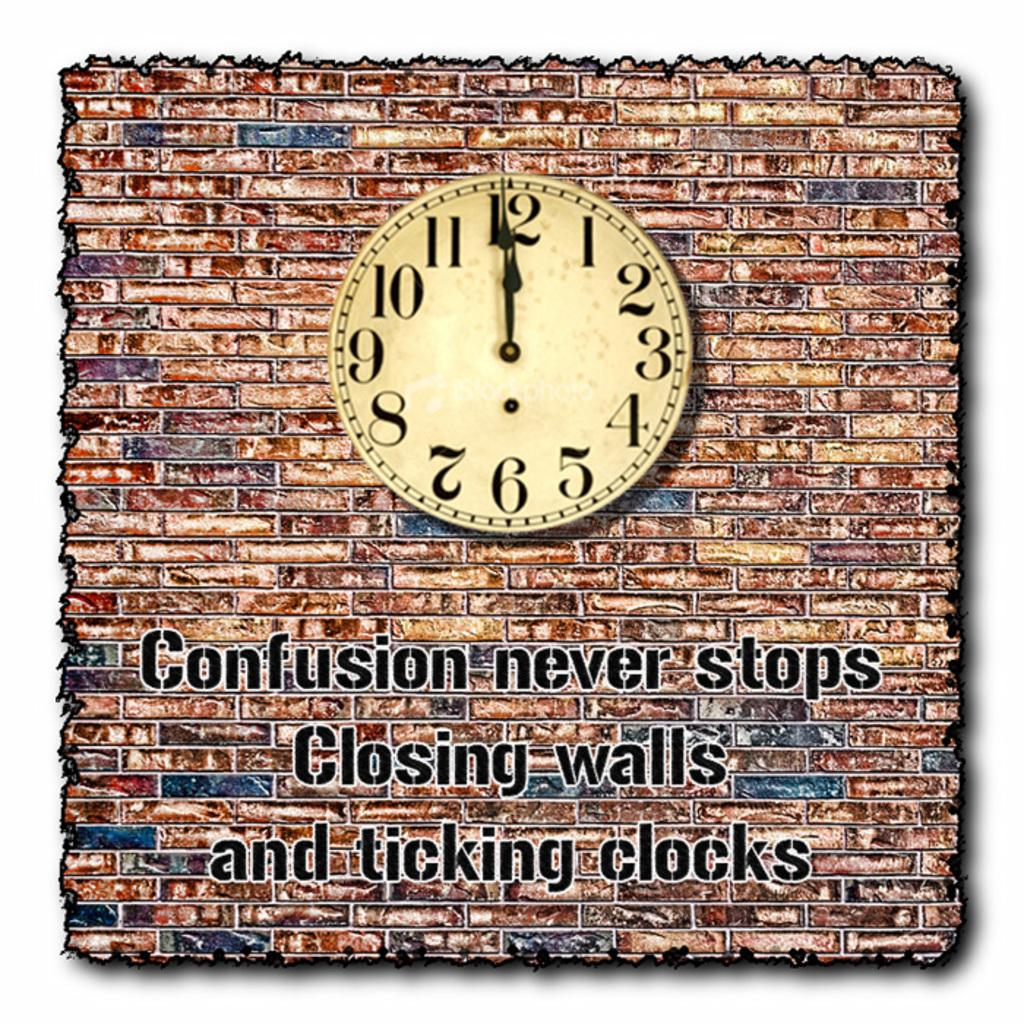Provide a one-sentence caption for the provided image. a clock is hanging on a wall with the words Confusion never stops closing walls and ticking clocks. 